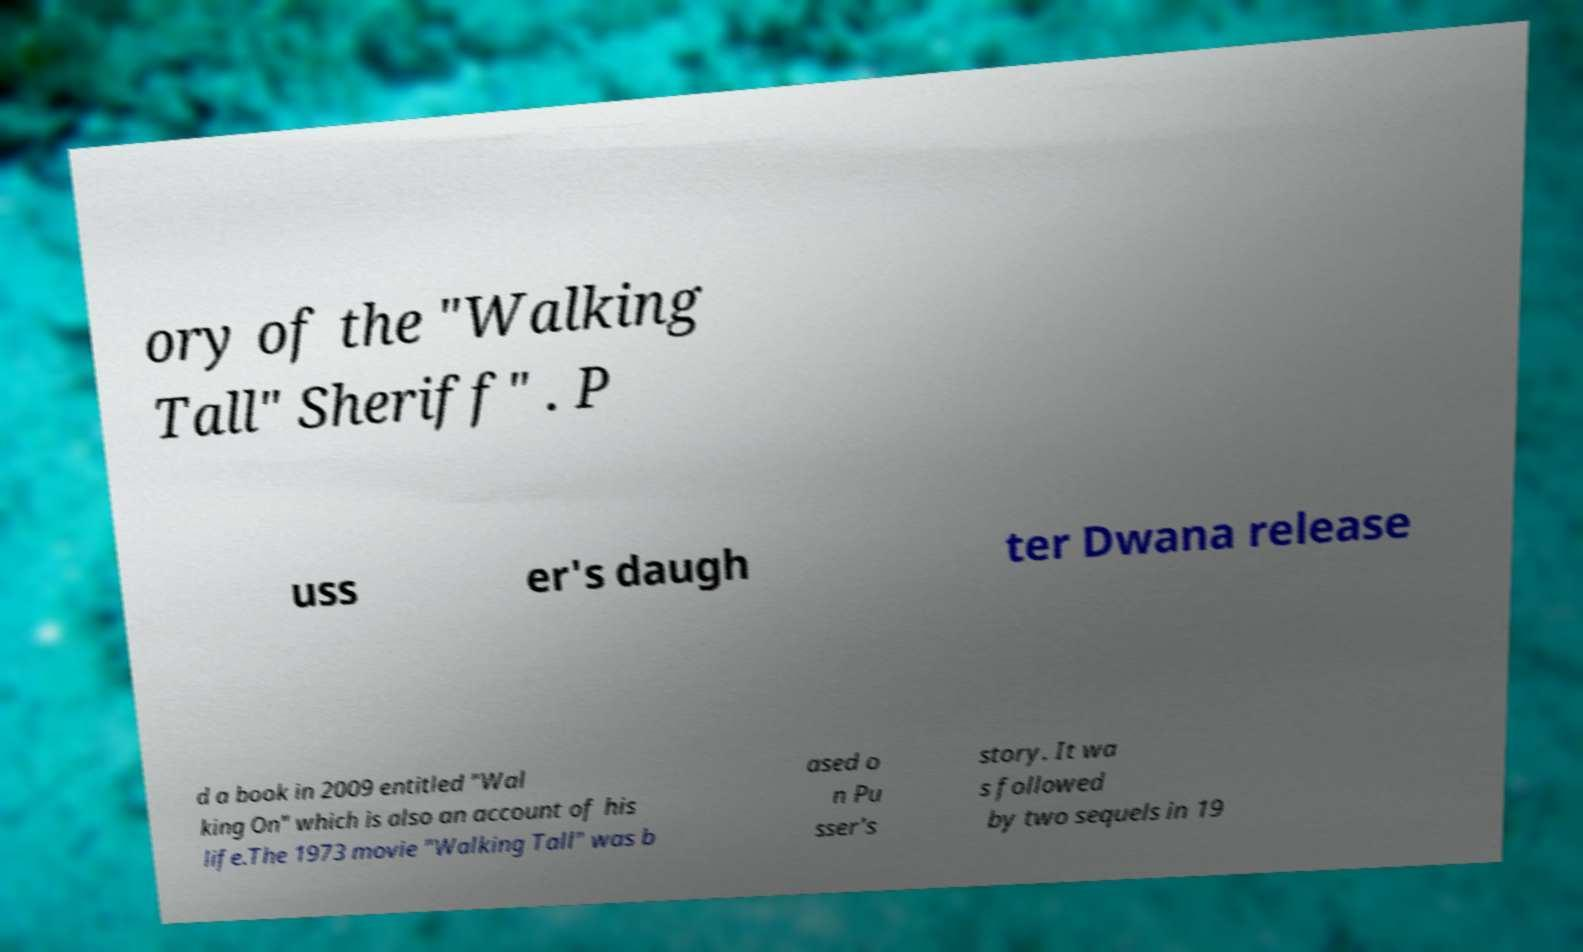Could you extract and type out the text from this image? ory of the "Walking Tall" Sheriff" . P uss er's daugh ter Dwana release d a book in 2009 entitled "Wal king On" which is also an account of his life.The 1973 movie "Walking Tall" was b ased o n Pu sser's story. It wa s followed by two sequels in 19 